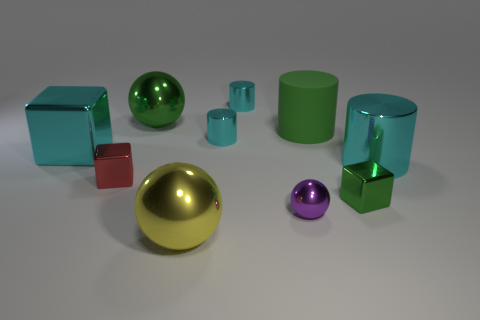The green object that is both behind the cyan block and in front of the big green metal ball is made of what material?
Offer a very short reply. Rubber. Are the big green thing to the left of the small purple metal thing and the block to the left of the small red thing made of the same material?
Ensure brevity in your answer.  Yes. What is the size of the yellow shiny sphere?
Give a very brief answer. Large. The green object that is the same shape as the red object is what size?
Provide a succinct answer. Small. There is a big yellow sphere; how many big matte things are to the left of it?
Offer a very short reply. 0. What color is the small shiny cylinder that is in front of the big shiny ball that is behind the yellow metallic ball?
Provide a short and direct response. Cyan. Are there any other things that are the same shape as the big yellow metallic thing?
Your answer should be very brief. Yes. Are there the same number of shiny objects behind the small sphere and big green things that are right of the yellow sphere?
Offer a terse response. No. How many spheres are either large things or small red shiny objects?
Give a very brief answer. 2. What number of other objects are there of the same material as the tiny green object?
Ensure brevity in your answer.  8. 